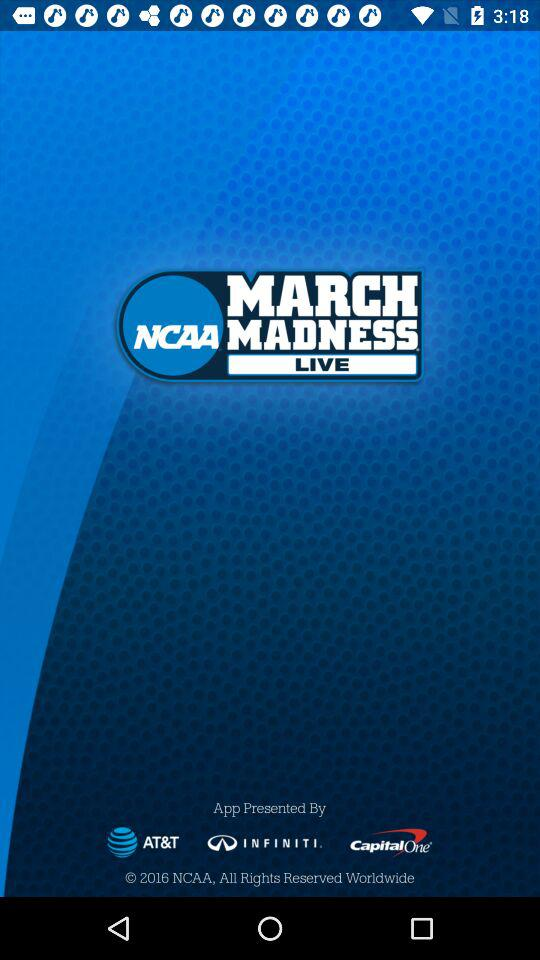What is the name of the application? The name of the application is "NCAA MARCH MADNESS LIVE". 